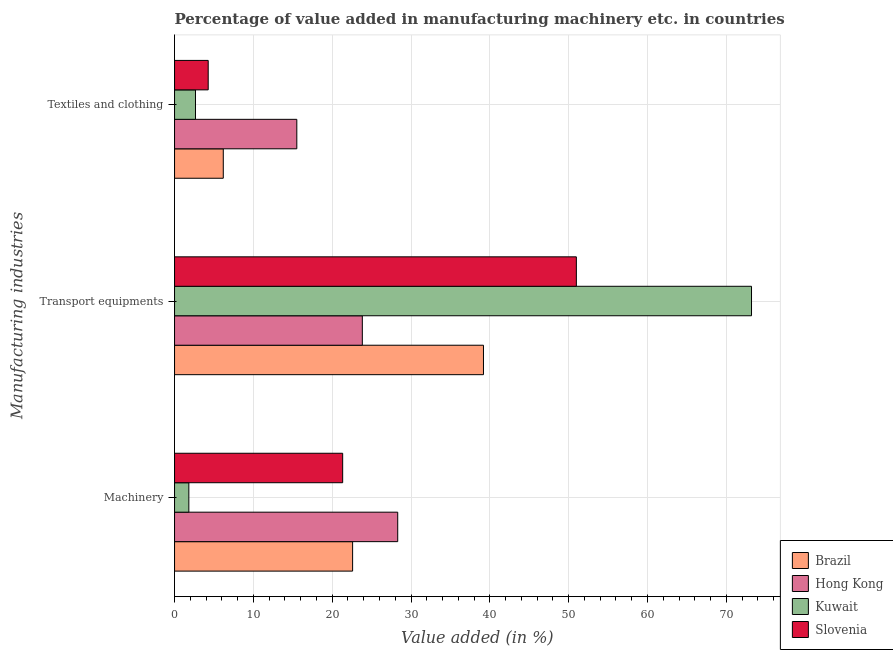How many bars are there on the 2nd tick from the top?
Make the answer very short. 4. How many bars are there on the 2nd tick from the bottom?
Give a very brief answer. 4. What is the label of the 3rd group of bars from the top?
Give a very brief answer. Machinery. What is the value added in manufacturing textile and clothing in Kuwait?
Your answer should be very brief. 2.66. Across all countries, what is the maximum value added in manufacturing machinery?
Provide a short and direct response. 28.31. Across all countries, what is the minimum value added in manufacturing textile and clothing?
Offer a very short reply. 2.66. In which country was the value added in manufacturing textile and clothing maximum?
Provide a succinct answer. Hong Kong. In which country was the value added in manufacturing textile and clothing minimum?
Provide a short and direct response. Kuwait. What is the total value added in manufacturing transport equipments in the graph?
Keep it short and to the point. 187.19. What is the difference between the value added in manufacturing machinery in Hong Kong and that in Slovenia?
Ensure brevity in your answer.  6.98. What is the difference between the value added in manufacturing machinery in Hong Kong and the value added in manufacturing textile and clothing in Brazil?
Your answer should be very brief. 22.13. What is the average value added in manufacturing transport equipments per country?
Offer a terse response. 46.8. What is the difference between the value added in manufacturing machinery and value added in manufacturing textile and clothing in Hong Kong?
Make the answer very short. 12.8. In how many countries, is the value added in manufacturing transport equipments greater than 60 %?
Your answer should be very brief. 1. What is the ratio of the value added in manufacturing machinery in Kuwait to that in Slovenia?
Provide a succinct answer. 0.09. Is the value added in manufacturing machinery in Slovenia less than that in Brazil?
Your answer should be compact. Yes. Is the difference between the value added in manufacturing transport equipments in Hong Kong and Slovenia greater than the difference between the value added in manufacturing textile and clothing in Hong Kong and Slovenia?
Keep it short and to the point. No. What is the difference between the highest and the second highest value added in manufacturing textile and clothing?
Make the answer very short. 9.33. What is the difference between the highest and the lowest value added in manufacturing textile and clothing?
Make the answer very short. 12.85. In how many countries, is the value added in manufacturing textile and clothing greater than the average value added in manufacturing textile and clothing taken over all countries?
Offer a very short reply. 1. Is the sum of the value added in manufacturing transport equipments in Slovenia and Hong Kong greater than the maximum value added in manufacturing machinery across all countries?
Keep it short and to the point. Yes. What does the 1st bar from the top in Textiles and clothing represents?
Ensure brevity in your answer.  Slovenia. What does the 4th bar from the bottom in Machinery represents?
Your answer should be very brief. Slovenia. How many countries are there in the graph?
Offer a very short reply. 4. What is the difference between two consecutive major ticks on the X-axis?
Provide a succinct answer. 10. Does the graph contain any zero values?
Ensure brevity in your answer.  No. Where does the legend appear in the graph?
Your answer should be very brief. Bottom right. What is the title of the graph?
Provide a succinct answer. Percentage of value added in manufacturing machinery etc. in countries. Does "Tonga" appear as one of the legend labels in the graph?
Offer a terse response. No. What is the label or title of the X-axis?
Provide a succinct answer. Value added (in %). What is the label or title of the Y-axis?
Make the answer very short. Manufacturing industries. What is the Value added (in %) of Brazil in Machinery?
Your answer should be very brief. 22.59. What is the Value added (in %) of Hong Kong in Machinery?
Your response must be concise. 28.31. What is the Value added (in %) of Kuwait in Machinery?
Offer a terse response. 1.81. What is the Value added (in %) in Slovenia in Machinery?
Your answer should be very brief. 21.33. What is the Value added (in %) in Brazil in Transport equipments?
Ensure brevity in your answer.  39.19. What is the Value added (in %) of Hong Kong in Transport equipments?
Your answer should be compact. 23.82. What is the Value added (in %) in Kuwait in Transport equipments?
Ensure brevity in your answer.  73.2. What is the Value added (in %) in Slovenia in Transport equipments?
Offer a very short reply. 50.98. What is the Value added (in %) in Brazil in Textiles and clothing?
Give a very brief answer. 6.18. What is the Value added (in %) of Hong Kong in Textiles and clothing?
Make the answer very short. 15.51. What is the Value added (in %) of Kuwait in Textiles and clothing?
Give a very brief answer. 2.66. What is the Value added (in %) in Slovenia in Textiles and clothing?
Offer a terse response. 4.27. Across all Manufacturing industries, what is the maximum Value added (in %) in Brazil?
Provide a succinct answer. 39.19. Across all Manufacturing industries, what is the maximum Value added (in %) of Hong Kong?
Make the answer very short. 28.31. Across all Manufacturing industries, what is the maximum Value added (in %) in Kuwait?
Keep it short and to the point. 73.2. Across all Manufacturing industries, what is the maximum Value added (in %) of Slovenia?
Offer a terse response. 50.98. Across all Manufacturing industries, what is the minimum Value added (in %) in Brazil?
Ensure brevity in your answer.  6.18. Across all Manufacturing industries, what is the minimum Value added (in %) in Hong Kong?
Make the answer very short. 15.51. Across all Manufacturing industries, what is the minimum Value added (in %) in Kuwait?
Your answer should be very brief. 1.81. Across all Manufacturing industries, what is the minimum Value added (in %) of Slovenia?
Offer a very short reply. 4.27. What is the total Value added (in %) in Brazil in the graph?
Ensure brevity in your answer.  67.97. What is the total Value added (in %) of Hong Kong in the graph?
Offer a terse response. 67.65. What is the total Value added (in %) of Kuwait in the graph?
Give a very brief answer. 77.67. What is the total Value added (in %) in Slovenia in the graph?
Keep it short and to the point. 76.58. What is the difference between the Value added (in %) in Brazil in Machinery and that in Transport equipments?
Keep it short and to the point. -16.6. What is the difference between the Value added (in %) of Hong Kong in Machinery and that in Transport equipments?
Provide a succinct answer. 4.49. What is the difference between the Value added (in %) in Kuwait in Machinery and that in Transport equipments?
Give a very brief answer. -71.39. What is the difference between the Value added (in %) in Slovenia in Machinery and that in Transport equipments?
Your response must be concise. -29.65. What is the difference between the Value added (in %) in Brazil in Machinery and that in Textiles and clothing?
Keep it short and to the point. 16.41. What is the difference between the Value added (in %) of Hong Kong in Machinery and that in Textiles and clothing?
Keep it short and to the point. 12.8. What is the difference between the Value added (in %) in Kuwait in Machinery and that in Textiles and clothing?
Your answer should be compact. -0.84. What is the difference between the Value added (in %) in Slovenia in Machinery and that in Textiles and clothing?
Offer a terse response. 17.06. What is the difference between the Value added (in %) of Brazil in Transport equipments and that in Textiles and clothing?
Ensure brevity in your answer.  33.01. What is the difference between the Value added (in %) of Hong Kong in Transport equipments and that in Textiles and clothing?
Offer a very short reply. 8.31. What is the difference between the Value added (in %) in Kuwait in Transport equipments and that in Textiles and clothing?
Ensure brevity in your answer.  70.54. What is the difference between the Value added (in %) of Slovenia in Transport equipments and that in Textiles and clothing?
Your answer should be very brief. 46.71. What is the difference between the Value added (in %) of Brazil in Machinery and the Value added (in %) of Hong Kong in Transport equipments?
Keep it short and to the point. -1.23. What is the difference between the Value added (in %) of Brazil in Machinery and the Value added (in %) of Kuwait in Transport equipments?
Keep it short and to the point. -50.61. What is the difference between the Value added (in %) of Brazil in Machinery and the Value added (in %) of Slovenia in Transport equipments?
Offer a terse response. -28.39. What is the difference between the Value added (in %) in Hong Kong in Machinery and the Value added (in %) in Kuwait in Transport equipments?
Provide a short and direct response. -44.89. What is the difference between the Value added (in %) of Hong Kong in Machinery and the Value added (in %) of Slovenia in Transport equipments?
Offer a terse response. -22.66. What is the difference between the Value added (in %) of Kuwait in Machinery and the Value added (in %) of Slovenia in Transport equipments?
Keep it short and to the point. -49.16. What is the difference between the Value added (in %) of Brazil in Machinery and the Value added (in %) of Hong Kong in Textiles and clothing?
Offer a very short reply. 7.08. What is the difference between the Value added (in %) of Brazil in Machinery and the Value added (in %) of Kuwait in Textiles and clothing?
Provide a succinct answer. 19.93. What is the difference between the Value added (in %) in Brazil in Machinery and the Value added (in %) in Slovenia in Textiles and clothing?
Provide a short and direct response. 18.32. What is the difference between the Value added (in %) in Hong Kong in Machinery and the Value added (in %) in Kuwait in Textiles and clothing?
Your answer should be compact. 25.66. What is the difference between the Value added (in %) in Hong Kong in Machinery and the Value added (in %) in Slovenia in Textiles and clothing?
Give a very brief answer. 24.05. What is the difference between the Value added (in %) of Kuwait in Machinery and the Value added (in %) of Slovenia in Textiles and clothing?
Keep it short and to the point. -2.45. What is the difference between the Value added (in %) of Brazil in Transport equipments and the Value added (in %) of Hong Kong in Textiles and clothing?
Ensure brevity in your answer.  23.68. What is the difference between the Value added (in %) of Brazil in Transport equipments and the Value added (in %) of Kuwait in Textiles and clothing?
Give a very brief answer. 36.54. What is the difference between the Value added (in %) of Brazil in Transport equipments and the Value added (in %) of Slovenia in Textiles and clothing?
Offer a terse response. 34.92. What is the difference between the Value added (in %) of Hong Kong in Transport equipments and the Value added (in %) of Kuwait in Textiles and clothing?
Your answer should be compact. 21.17. What is the difference between the Value added (in %) of Hong Kong in Transport equipments and the Value added (in %) of Slovenia in Textiles and clothing?
Provide a succinct answer. 19.55. What is the difference between the Value added (in %) of Kuwait in Transport equipments and the Value added (in %) of Slovenia in Textiles and clothing?
Ensure brevity in your answer.  68.93. What is the average Value added (in %) in Brazil per Manufacturing industries?
Your response must be concise. 22.66. What is the average Value added (in %) in Hong Kong per Manufacturing industries?
Give a very brief answer. 22.55. What is the average Value added (in %) of Kuwait per Manufacturing industries?
Offer a very short reply. 25.89. What is the average Value added (in %) of Slovenia per Manufacturing industries?
Make the answer very short. 25.53. What is the difference between the Value added (in %) in Brazil and Value added (in %) in Hong Kong in Machinery?
Your answer should be compact. -5.72. What is the difference between the Value added (in %) of Brazil and Value added (in %) of Kuwait in Machinery?
Provide a succinct answer. 20.78. What is the difference between the Value added (in %) of Brazil and Value added (in %) of Slovenia in Machinery?
Provide a succinct answer. 1.26. What is the difference between the Value added (in %) of Hong Kong and Value added (in %) of Slovenia in Machinery?
Give a very brief answer. 6.99. What is the difference between the Value added (in %) of Kuwait and Value added (in %) of Slovenia in Machinery?
Your answer should be compact. -19.52. What is the difference between the Value added (in %) of Brazil and Value added (in %) of Hong Kong in Transport equipments?
Offer a very short reply. 15.37. What is the difference between the Value added (in %) in Brazil and Value added (in %) in Kuwait in Transport equipments?
Keep it short and to the point. -34.01. What is the difference between the Value added (in %) of Brazil and Value added (in %) of Slovenia in Transport equipments?
Give a very brief answer. -11.78. What is the difference between the Value added (in %) in Hong Kong and Value added (in %) in Kuwait in Transport equipments?
Offer a very short reply. -49.38. What is the difference between the Value added (in %) of Hong Kong and Value added (in %) of Slovenia in Transport equipments?
Give a very brief answer. -27.15. What is the difference between the Value added (in %) of Kuwait and Value added (in %) of Slovenia in Transport equipments?
Provide a short and direct response. 22.22. What is the difference between the Value added (in %) in Brazil and Value added (in %) in Hong Kong in Textiles and clothing?
Provide a succinct answer. -9.33. What is the difference between the Value added (in %) in Brazil and Value added (in %) in Kuwait in Textiles and clothing?
Make the answer very short. 3.53. What is the difference between the Value added (in %) of Brazil and Value added (in %) of Slovenia in Textiles and clothing?
Keep it short and to the point. 1.91. What is the difference between the Value added (in %) of Hong Kong and Value added (in %) of Kuwait in Textiles and clothing?
Provide a short and direct response. 12.85. What is the difference between the Value added (in %) of Hong Kong and Value added (in %) of Slovenia in Textiles and clothing?
Offer a terse response. 11.24. What is the difference between the Value added (in %) in Kuwait and Value added (in %) in Slovenia in Textiles and clothing?
Your answer should be compact. -1.61. What is the ratio of the Value added (in %) in Brazil in Machinery to that in Transport equipments?
Keep it short and to the point. 0.58. What is the ratio of the Value added (in %) in Hong Kong in Machinery to that in Transport equipments?
Offer a very short reply. 1.19. What is the ratio of the Value added (in %) of Kuwait in Machinery to that in Transport equipments?
Give a very brief answer. 0.02. What is the ratio of the Value added (in %) of Slovenia in Machinery to that in Transport equipments?
Your answer should be very brief. 0.42. What is the ratio of the Value added (in %) in Brazil in Machinery to that in Textiles and clothing?
Provide a short and direct response. 3.65. What is the ratio of the Value added (in %) in Hong Kong in Machinery to that in Textiles and clothing?
Ensure brevity in your answer.  1.83. What is the ratio of the Value added (in %) of Kuwait in Machinery to that in Textiles and clothing?
Provide a short and direct response. 0.68. What is the ratio of the Value added (in %) of Slovenia in Machinery to that in Textiles and clothing?
Keep it short and to the point. 5. What is the ratio of the Value added (in %) in Brazil in Transport equipments to that in Textiles and clothing?
Give a very brief answer. 6.34. What is the ratio of the Value added (in %) in Hong Kong in Transport equipments to that in Textiles and clothing?
Give a very brief answer. 1.54. What is the ratio of the Value added (in %) of Kuwait in Transport equipments to that in Textiles and clothing?
Your answer should be compact. 27.55. What is the ratio of the Value added (in %) of Slovenia in Transport equipments to that in Textiles and clothing?
Make the answer very short. 11.94. What is the difference between the highest and the second highest Value added (in %) of Brazil?
Provide a short and direct response. 16.6. What is the difference between the highest and the second highest Value added (in %) of Hong Kong?
Give a very brief answer. 4.49. What is the difference between the highest and the second highest Value added (in %) of Kuwait?
Provide a succinct answer. 70.54. What is the difference between the highest and the second highest Value added (in %) of Slovenia?
Provide a succinct answer. 29.65. What is the difference between the highest and the lowest Value added (in %) of Brazil?
Give a very brief answer. 33.01. What is the difference between the highest and the lowest Value added (in %) of Hong Kong?
Your answer should be compact. 12.8. What is the difference between the highest and the lowest Value added (in %) of Kuwait?
Offer a very short reply. 71.39. What is the difference between the highest and the lowest Value added (in %) of Slovenia?
Offer a terse response. 46.71. 